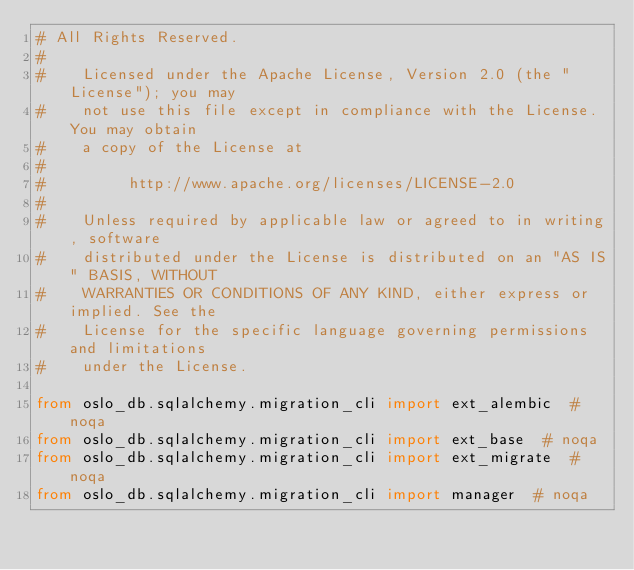<code> <loc_0><loc_0><loc_500><loc_500><_Python_># All Rights Reserved.
#
#    Licensed under the Apache License, Version 2.0 (the "License"); you may
#    not use this file except in compliance with the License. You may obtain
#    a copy of the License at
#
#         http://www.apache.org/licenses/LICENSE-2.0
#
#    Unless required by applicable law or agreed to in writing, software
#    distributed under the License is distributed on an "AS IS" BASIS, WITHOUT
#    WARRANTIES OR CONDITIONS OF ANY KIND, either express or implied. See the
#    License for the specific language governing permissions and limitations
#    under the License.

from oslo_db.sqlalchemy.migration_cli import ext_alembic  # noqa
from oslo_db.sqlalchemy.migration_cli import ext_base  # noqa
from oslo_db.sqlalchemy.migration_cli import ext_migrate  # noqa
from oslo_db.sqlalchemy.migration_cli import manager  # noqa
</code> 